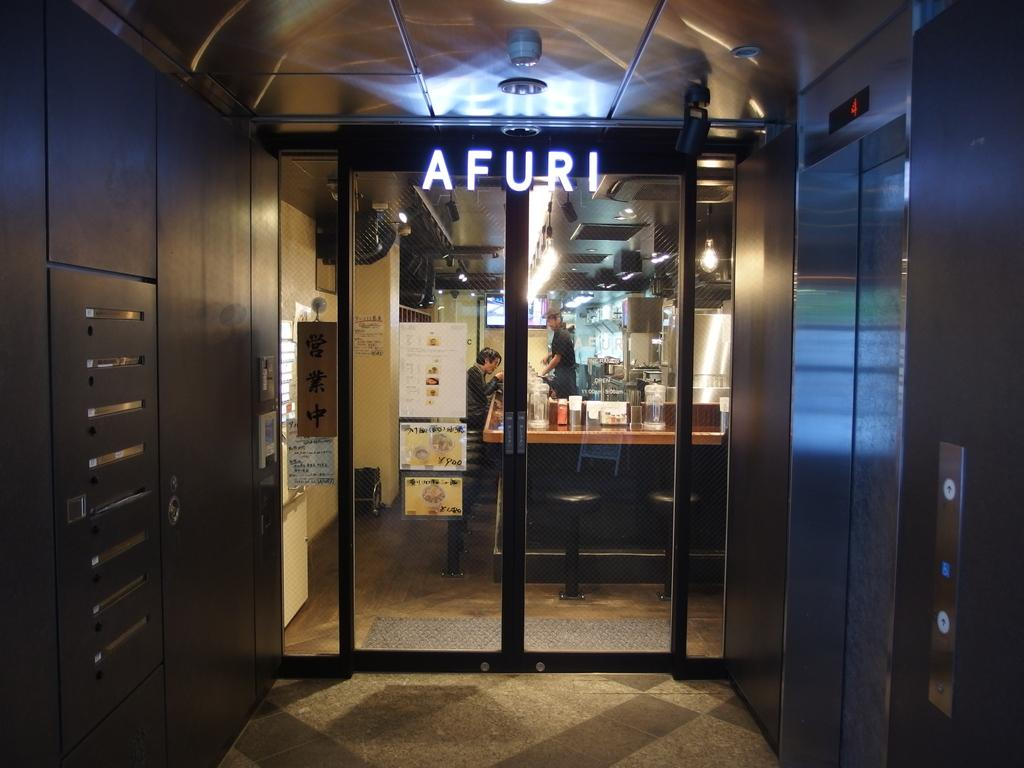<image>
Provide a brief description of the given image. A glass door by an elevator has a sign that says Afuri. 